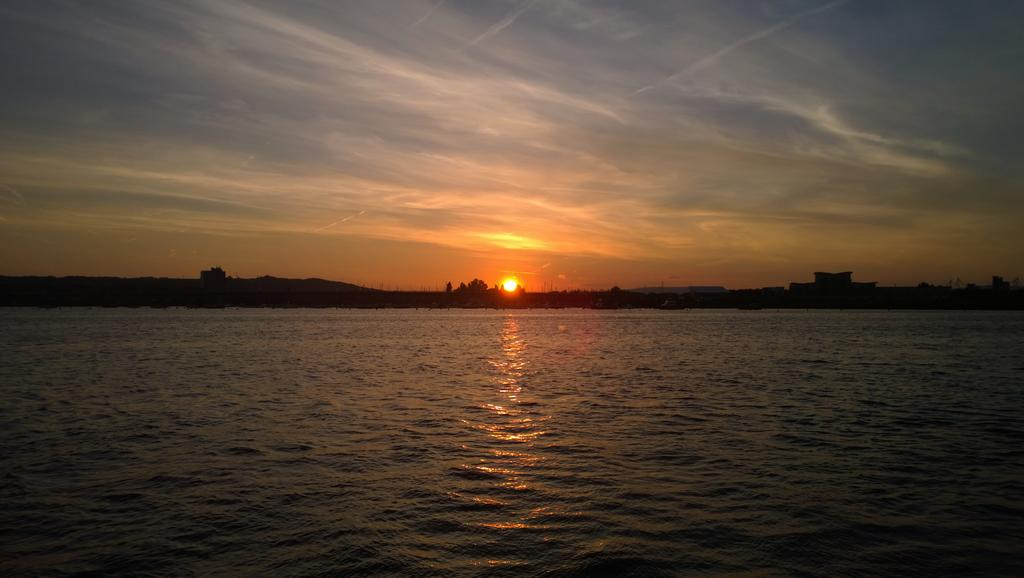What is the primary element visible in the image? There is water in the image. What can be seen in the distance behind the water? There are trees and houses in the background of the image. What is the source of light in the image? The sun is visible in the image. What type of net can be seen catching fish in the image? There is no net present in the image, and no fishing activity is depicted. 